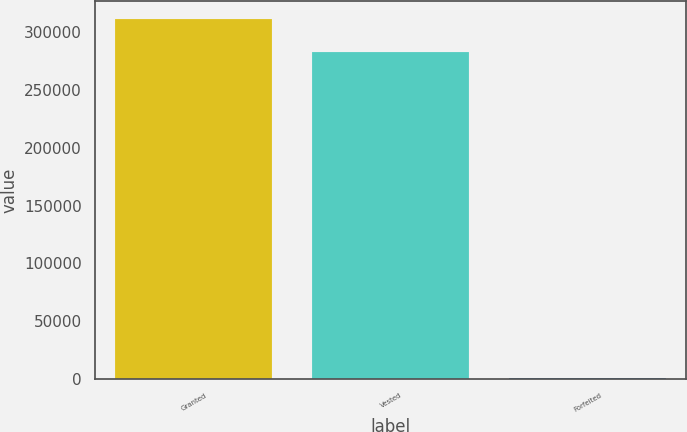Convert chart. <chart><loc_0><loc_0><loc_500><loc_500><bar_chart><fcel>Granted<fcel>Vested<fcel>Forfeited<nl><fcel>311388<fcel>283080<fcel>1038<nl></chart> 